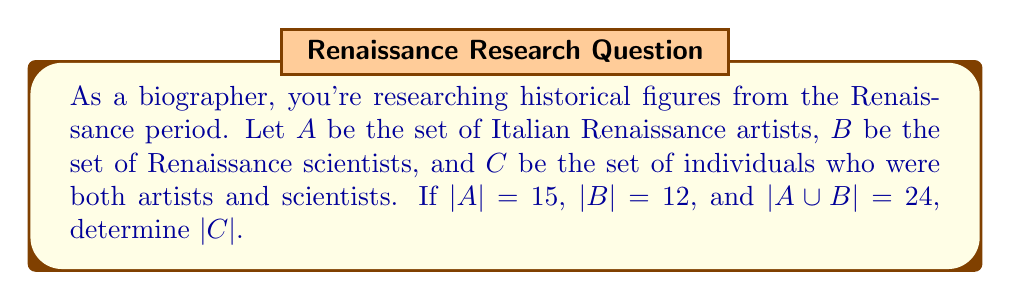Help me with this question. To solve this problem, we'll use set theory concepts, particularly the principle of inclusion-exclusion.

1) Let's define our sets:
   $A$: Italian Renaissance artists
   $B$: Renaissance scientists
   $C$: Individuals who were both artists and scientists

2) We're given:
   $|A| = 15$
   $|B| = 12$
   $|A \cup B| = 24$

3) The principle of inclusion-exclusion states:
   $|A \cup B| = |A| + |B| - |A \cap B|$

4) We can see that $C = A \cap B$, as $C$ represents individuals who belong to both $A$ and $B$.

5) Substituting our known values into the formula:
   $24 = 15 + 12 - |C|$

6) Simplifying:
   $24 = 27 - |C|$

7) Solving for $|C|$:
   $|C| = 27 - 24 = 3$

Therefore, there are 3 individuals who were both Italian Renaissance artists and Renaissance scientists.

This method of categorization using set theory allows us as biographers to efficiently organize and analyze historical figures across different domains, revealing interesting intersections in their lives and works.
Answer: $|C| = 3$ 